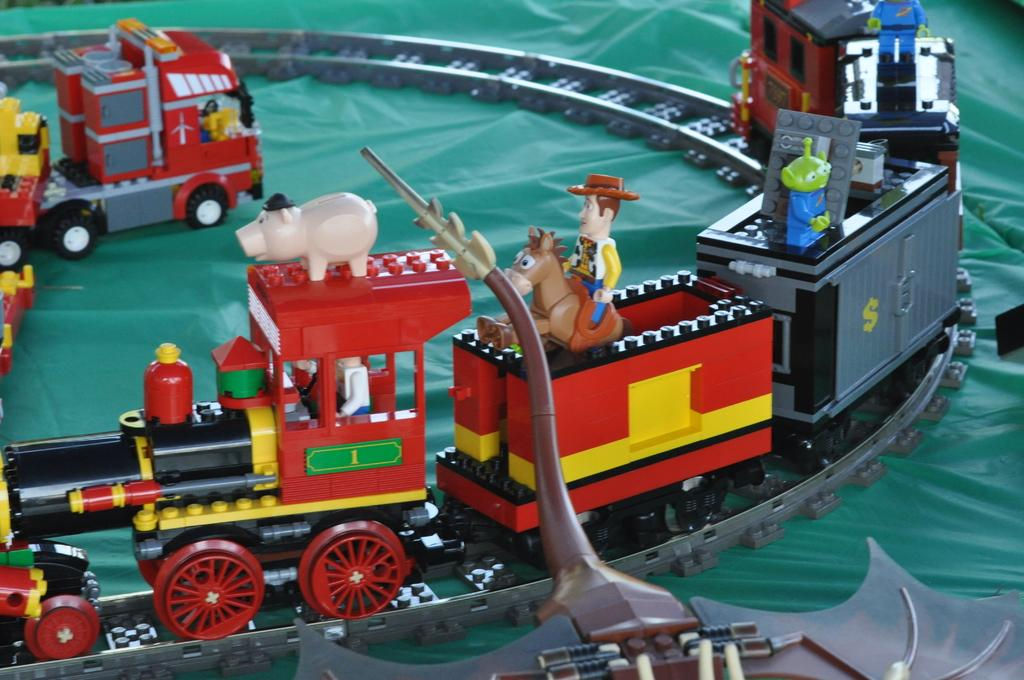What is the color of the surface in the image? The surface in the image is green. What is located on the green surface? There is a toy train on the green surface. What is the toy train doing on the green surface? The toy train is on a track. What can be found on the toy train? There are toys on the toy train. How does the train contribute to world peace in the image? The image does not depict the train's impact on world peace, as it is focused on the toy train's presence on a green surface. 